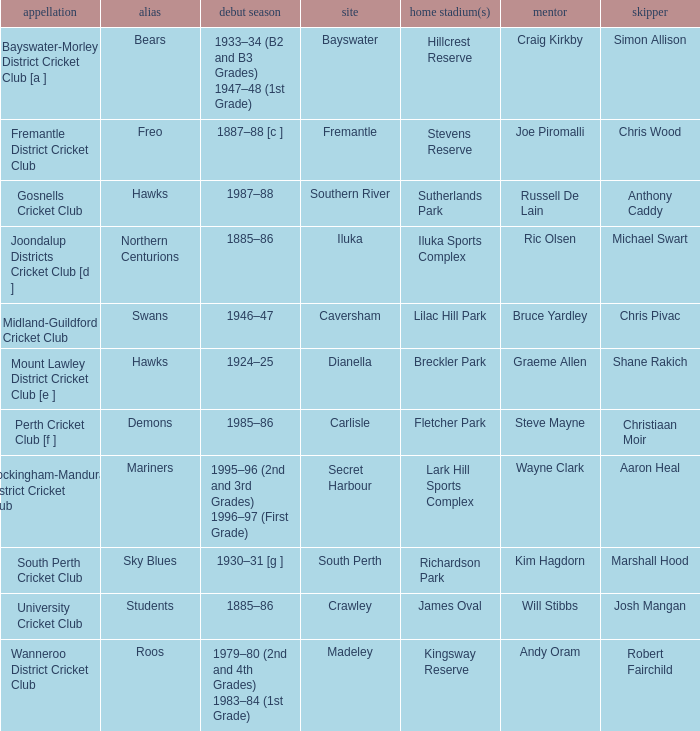What is the dates where Hillcrest Reserve is the home grounds? 1933–34 (B2 and B3 Grades) 1947–48 (1st Grade). 